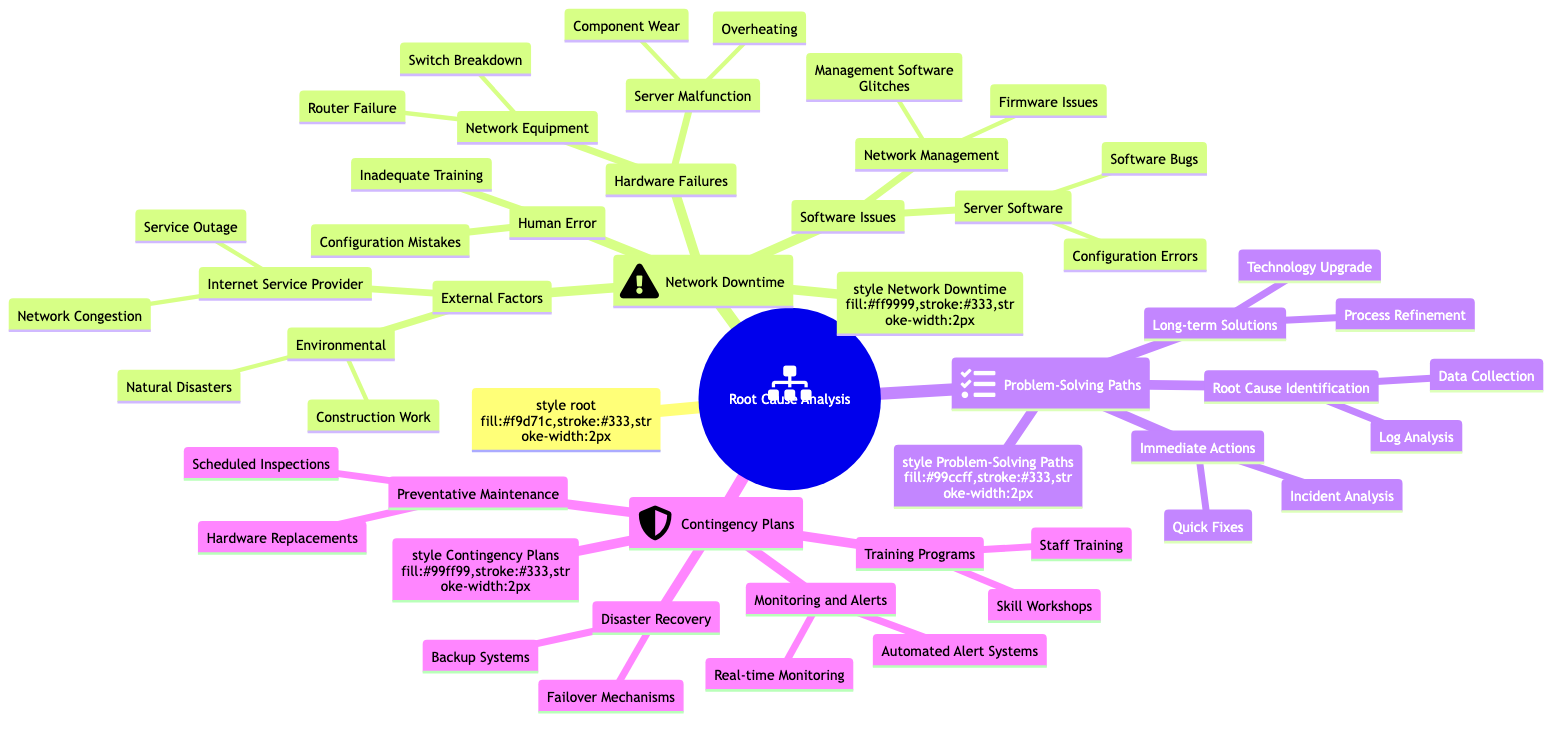What are the main categories of causes for Network Downtime? The diagram lists four main categories under Network Downtime: External Factors, Hardware Failures, Software Issues, and Human Error. Each category is a node branching from the main topic, indicating significant contributors to network downtime.
Answer: External Factors, Hardware Failures, Software Issues, Human Error How many immediate actions are outlined in the Problem-Solving Paths? Under the Problem-Solving Paths section, there are two immediate actions: Incident Analysis and Quick Fixes. Both actions are child nodes under Immediate Actions, directly indicating they are part of the problem-solving process.
Answer: 2 Which external factor is specifically mentioned regarding Internet Service Providers? The External Factors section includes Internet Service Provider, under which there are specific causes listed: Service Outage and Network Congestion. Therefore, both represent external factors related directly to the ISP.
Answer: Service Outage and Network Congestion What is the relationship between Software Issues and Hardware Failures? Both Software Issues and Hardware Failures are top-level categories listed under the Network Downtime node. This indicates they are both primary sources of downtime, but they are separate categories, representing different types of causes related to network issues.
Answer: They are separate categories under Network Downtime What are the two long-term solutions outlined in the Problem-Solving Paths? The Long-term Solutions section details two proposed strategies: Process Refinement and Technology Upgrade. Both are necessary for addressing root issues in network downtime and are aimed at long-lasting improvements.
Answer: Process Refinement, Technology Upgrade How many contingency plans are listed in the diagram? Under Contingency Plans, there are four identified plans: Disaster Recovery, Preventative Maintenance, Training Programs, and Monitoring and Alerts. This counts to a total of four distinct contingency strategies for network downtime management.
Answer: 4 Which category includes both Backup Systems and Failover Mechanisms? Both Backup Systems and Failover Mechanisms are part of the Disaster Recovery node, indicating they are strategies designed to recover from significant errors or outages in the network.
Answer: Disaster Recovery What type of training programs are suggested in the contingency plans? The Training Programs node under Contingency Plans suggests two types: Staff Training and Skill Workshops. These are aimed at improving the competencies of personnel managing and troubleshooting network issues.
Answer: Staff Training, Skill Workshops 